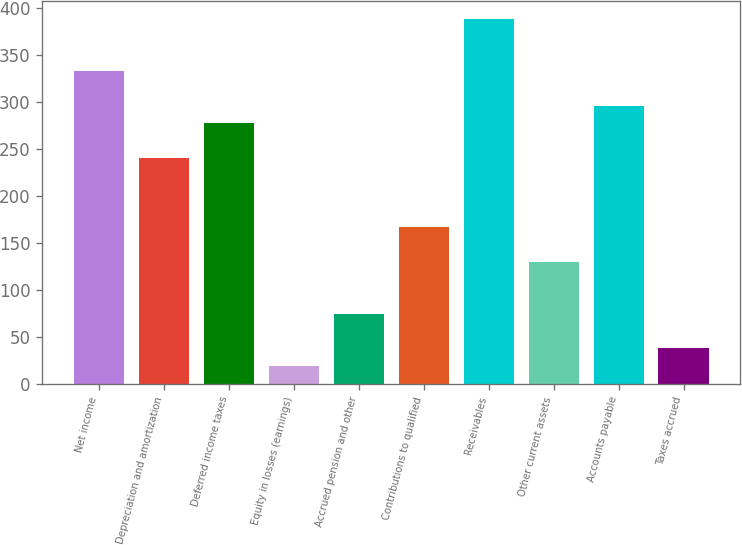Convert chart. <chart><loc_0><loc_0><loc_500><loc_500><bar_chart><fcel>Net income<fcel>Depreciation and amortization<fcel>Deferred income taxes<fcel>Equity in losses (earnings)<fcel>Accrued pension and other<fcel>Contributions to qualified<fcel>Receivables<fcel>Other current assets<fcel>Accounts payable<fcel>Taxes accrued<nl><fcel>332.2<fcel>240.2<fcel>277<fcel>19.4<fcel>74.6<fcel>166.6<fcel>387.4<fcel>129.8<fcel>295.4<fcel>37.8<nl></chart> 